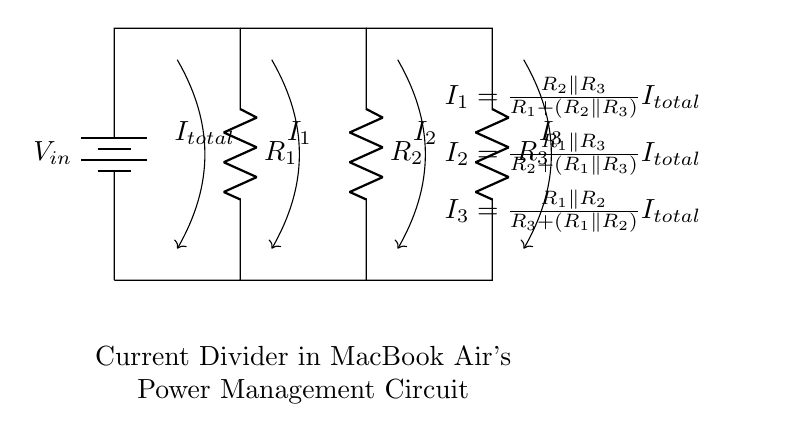What is the input voltage of the circuit? The input voltage is denoted as V_in and is represented by the battery in the circuit diagram.
Answer: V_in What are the resistances present in this circuit? The resistances in the circuit are labeled as R_1, R_2, and R_3, which are connected to the input voltage in a way that facilitates current division.
Answer: R_1, R_2, R_3 What current flows through resistor 1 when the total current is given? The current through resistor 1 is calculated using the formula provided in the diagram, specifically I_1 = (R_2 parallel R_3) / (R_1 + (R_2 parallel R_3)) I_total.
Answer: I_1 How many resistors are used in the current divider? The circuit contains three resistors: R_1, R_2, and R_3, which are integral to the current division process.
Answer: Three What is the relationship between I_total and the individual currents? The total current I_total is the sum of the individual currents I_1, I_2, and I_3 flowing through the other resistors as per the current divider principle.
Answer: I_total = I_1 + I_2 + I_3 What is the formula to calculate current through resistor 2? The current through resistor 2 is given by the formula: I_2 = (R_1 parallel R_3) / (R_2 + (R_1 parallel R_3)) I_total, indicating how the current is divided based on the resistances.
Answer: I_2 